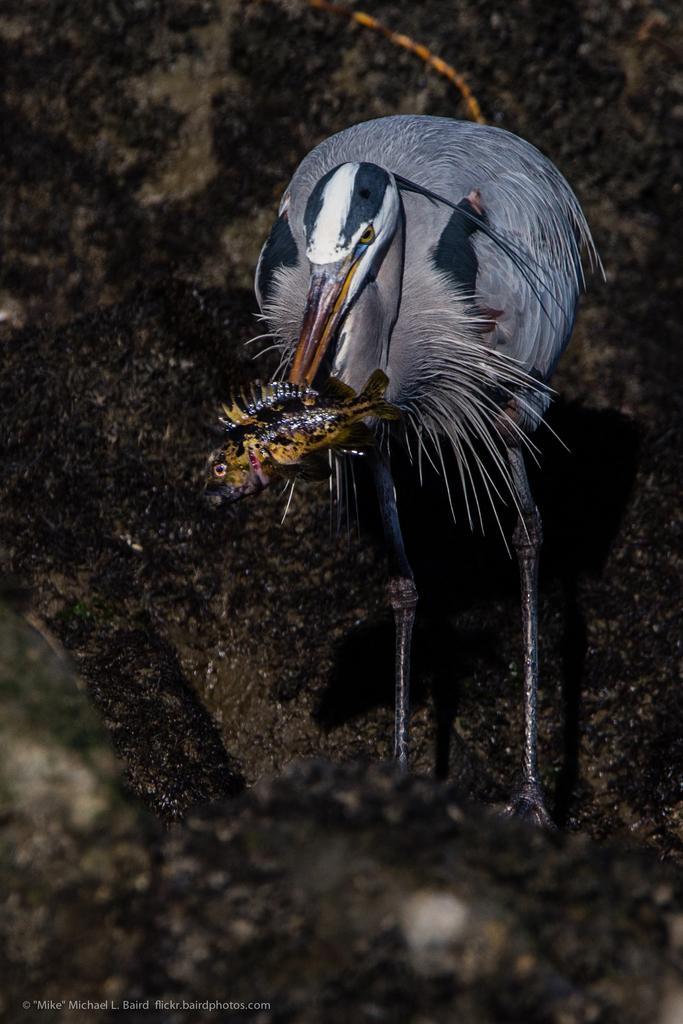Describe this image in one or two sentences. In this picture there is a bird standing and holding the fish. At the bottom there are stones. At the bottom left there is text. 